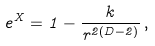Convert formula to latex. <formula><loc_0><loc_0><loc_500><loc_500>e ^ { X } = 1 - \frac { k } { r ^ { 2 ( D - 2 ) } } \, ,</formula> 